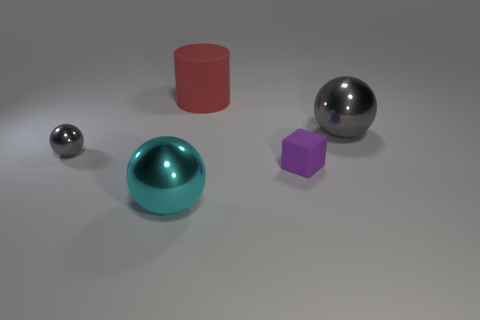Subtract all gray balls. How many balls are left? 1 Subtract all yellow cubes. How many gray spheres are left? 2 Add 5 gray metallic things. How many objects exist? 10 Subtract 0 brown blocks. How many objects are left? 5 Subtract all spheres. How many objects are left? 2 Subtract all green spheres. Subtract all brown cubes. How many spheres are left? 3 Subtract all small brown cylinders. Subtract all tiny gray things. How many objects are left? 4 Add 5 purple rubber blocks. How many purple rubber blocks are left? 6 Add 5 tiny rubber objects. How many tiny rubber objects exist? 6 